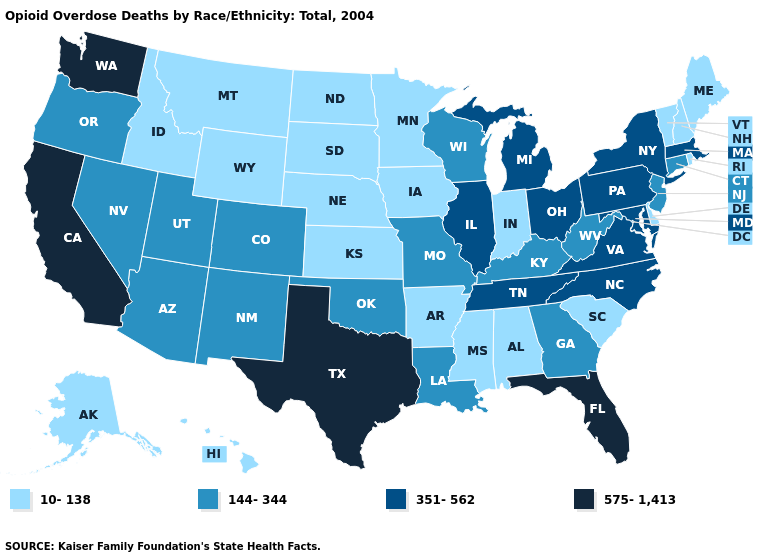What is the value of Alabama?
Write a very short answer. 10-138. Name the states that have a value in the range 575-1,413?
Give a very brief answer. California, Florida, Texas, Washington. Name the states that have a value in the range 351-562?
Answer briefly. Illinois, Maryland, Massachusetts, Michigan, New York, North Carolina, Ohio, Pennsylvania, Tennessee, Virginia. What is the highest value in the USA?
Answer briefly. 575-1,413. What is the lowest value in the USA?
Write a very short answer. 10-138. Is the legend a continuous bar?
Answer briefly. No. What is the value of Oregon?
Quick response, please. 144-344. Among the states that border Alabama , does Tennessee have the lowest value?
Quick response, please. No. What is the lowest value in the Northeast?
Answer briefly. 10-138. Does Idaho have the highest value in the USA?
Short answer required. No. What is the value of Connecticut?
Give a very brief answer. 144-344. Which states have the highest value in the USA?
Write a very short answer. California, Florida, Texas, Washington. What is the highest value in the USA?
Write a very short answer. 575-1,413. What is the value of Vermont?
Write a very short answer. 10-138. What is the value of Georgia?
Concise answer only. 144-344. 